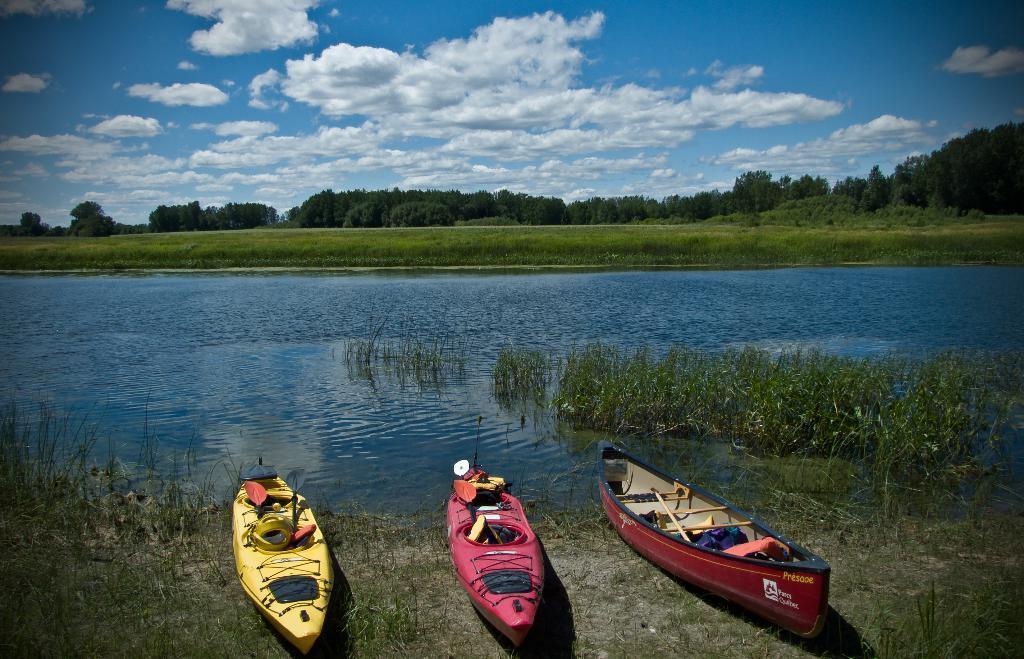How would you summarize this image in a sentence or two? In this image we can see boats placed on the river bed, grass, river, trees and sky with clouds. 